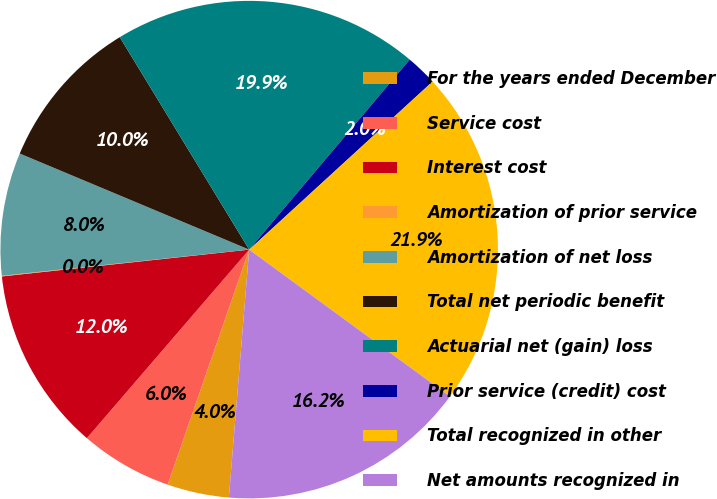Convert chart to OTSL. <chart><loc_0><loc_0><loc_500><loc_500><pie_chart><fcel>For the years ended December<fcel>Service cost<fcel>Interest cost<fcel>Amortization of prior service<fcel>Amortization of net loss<fcel>Total net periodic benefit<fcel>Actuarial net (gain) loss<fcel>Prior service (credit) cost<fcel>Total recognized in other<fcel>Net amounts recognized in<nl><fcel>4.01%<fcel>6.0%<fcel>11.97%<fcel>0.04%<fcel>7.99%<fcel>9.98%<fcel>19.87%<fcel>2.03%<fcel>21.86%<fcel>16.25%<nl></chart> 